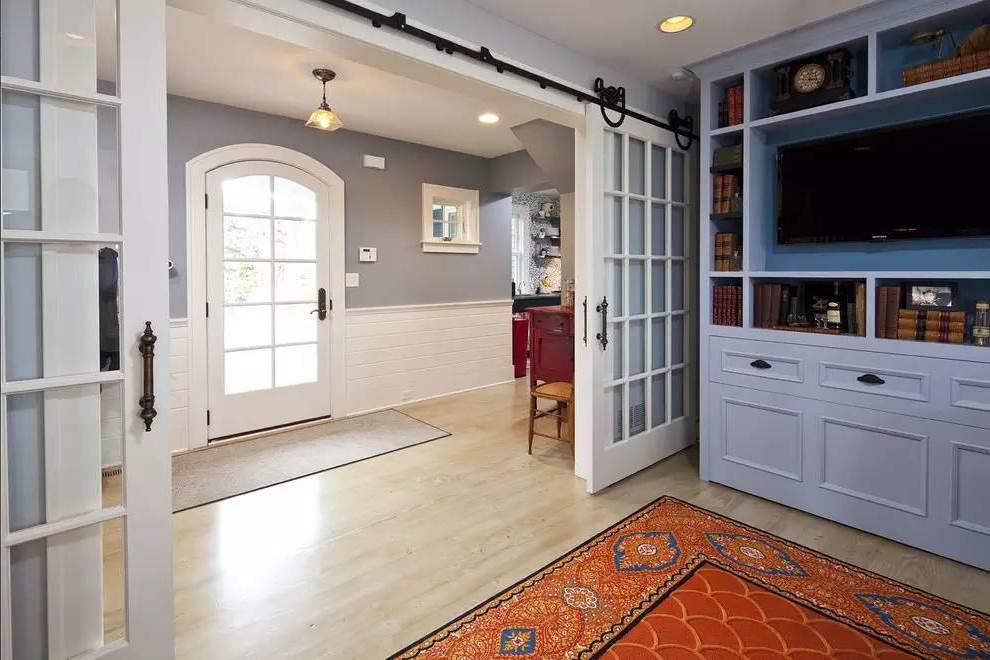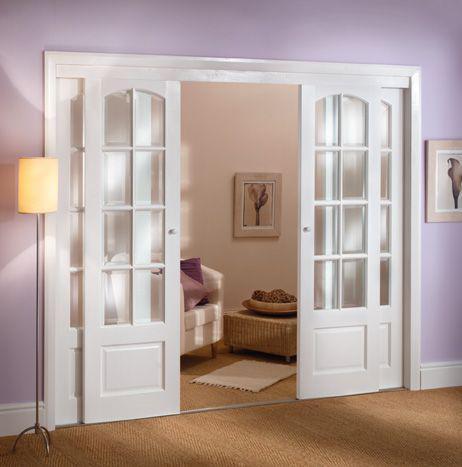The first image is the image on the left, the second image is the image on the right. Examine the images to the left and right. Is the description "An image shows a door open wide enough to walk through." accurate? Answer yes or no. Yes. The first image is the image on the left, the second image is the image on the right. For the images shown, is this caption "Both doors have less than a 12 inch opening." true? Answer yes or no. No. 